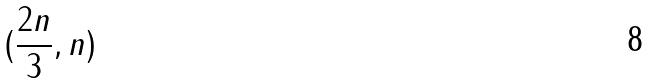<formula> <loc_0><loc_0><loc_500><loc_500>( \frac { 2 n } { 3 } , n )</formula> 